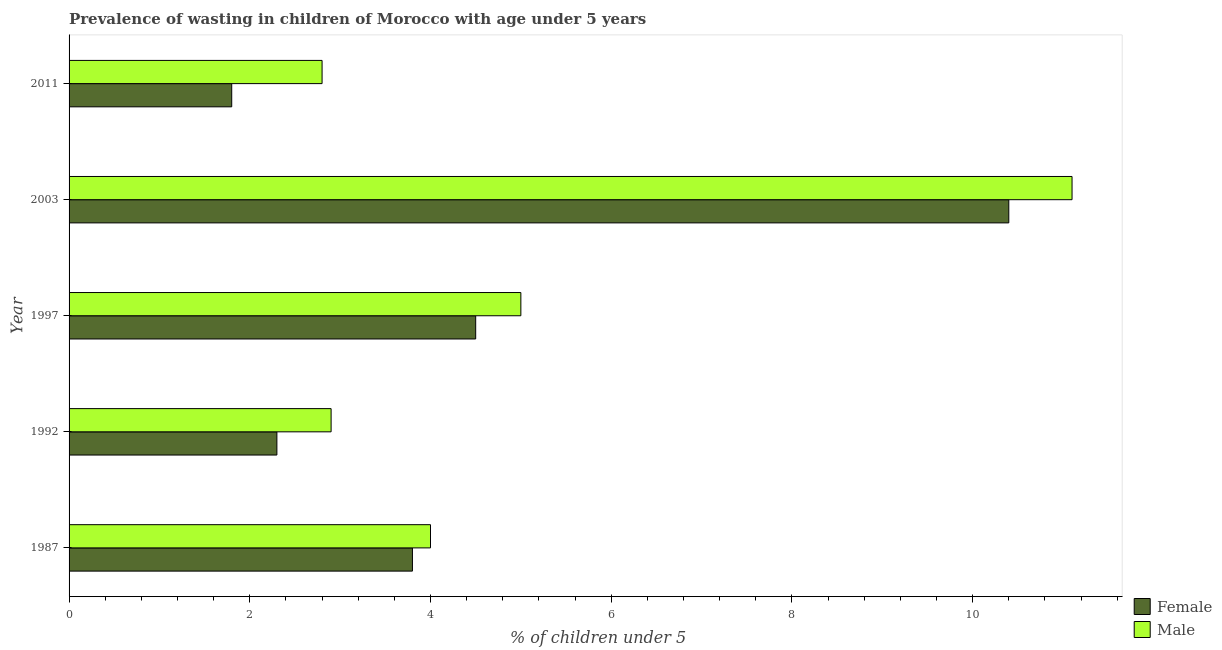Are the number of bars per tick equal to the number of legend labels?
Provide a short and direct response. Yes. Are the number of bars on each tick of the Y-axis equal?
Keep it short and to the point. Yes. How many bars are there on the 5th tick from the top?
Make the answer very short. 2. In how many cases, is the number of bars for a given year not equal to the number of legend labels?
Offer a terse response. 0. What is the percentage of undernourished female children in 2003?
Keep it short and to the point. 10.4. Across all years, what is the maximum percentage of undernourished male children?
Make the answer very short. 11.1. Across all years, what is the minimum percentage of undernourished male children?
Keep it short and to the point. 2.8. In which year was the percentage of undernourished male children maximum?
Give a very brief answer. 2003. In which year was the percentage of undernourished male children minimum?
Your answer should be very brief. 2011. What is the total percentage of undernourished male children in the graph?
Offer a very short reply. 25.8. What is the difference between the percentage of undernourished female children in 1992 and that in 2011?
Offer a very short reply. 0.5. What is the difference between the percentage of undernourished male children in 1997 and the percentage of undernourished female children in 1987?
Your response must be concise. 1.2. What is the average percentage of undernourished female children per year?
Ensure brevity in your answer.  4.56. In the year 2011, what is the difference between the percentage of undernourished male children and percentage of undernourished female children?
Your answer should be compact. 1. What is the ratio of the percentage of undernourished male children in 1987 to that in 2003?
Your answer should be very brief. 0.36. Is the percentage of undernourished male children in 1987 less than that in 1992?
Offer a very short reply. No. Is the difference between the percentage of undernourished male children in 1987 and 2003 greater than the difference between the percentage of undernourished female children in 1987 and 2003?
Your answer should be compact. No. What is the difference between the highest and the second highest percentage of undernourished male children?
Your response must be concise. 6.1. How many bars are there?
Make the answer very short. 10. What is the difference between two consecutive major ticks on the X-axis?
Keep it short and to the point. 2. Does the graph contain grids?
Provide a short and direct response. No. Where does the legend appear in the graph?
Your response must be concise. Bottom right. How are the legend labels stacked?
Provide a succinct answer. Vertical. What is the title of the graph?
Offer a terse response. Prevalence of wasting in children of Morocco with age under 5 years. Does "Sanitation services" appear as one of the legend labels in the graph?
Your response must be concise. No. What is the label or title of the X-axis?
Provide a short and direct response.  % of children under 5. What is the  % of children under 5 in Female in 1987?
Make the answer very short. 3.8. What is the  % of children under 5 in Female in 1992?
Ensure brevity in your answer.  2.3. What is the  % of children under 5 in Male in 1992?
Provide a succinct answer. 2.9. What is the  % of children under 5 in Female in 1997?
Offer a very short reply. 4.5. What is the  % of children under 5 in Male in 1997?
Give a very brief answer. 5. What is the  % of children under 5 of Female in 2003?
Offer a very short reply. 10.4. What is the  % of children under 5 in Male in 2003?
Offer a terse response. 11.1. What is the  % of children under 5 in Female in 2011?
Provide a short and direct response. 1.8. What is the  % of children under 5 in Male in 2011?
Your response must be concise. 2.8. Across all years, what is the maximum  % of children under 5 of Female?
Make the answer very short. 10.4. Across all years, what is the maximum  % of children under 5 in Male?
Make the answer very short. 11.1. Across all years, what is the minimum  % of children under 5 of Female?
Provide a succinct answer. 1.8. Across all years, what is the minimum  % of children under 5 in Male?
Your answer should be compact. 2.8. What is the total  % of children under 5 in Female in the graph?
Give a very brief answer. 22.8. What is the total  % of children under 5 in Male in the graph?
Give a very brief answer. 25.8. What is the difference between the  % of children under 5 in Female in 1987 and that in 1997?
Ensure brevity in your answer.  -0.7. What is the difference between the  % of children under 5 in Male in 1987 and that in 1997?
Give a very brief answer. -1. What is the difference between the  % of children under 5 of Female in 1987 and that in 2003?
Your response must be concise. -6.6. What is the difference between the  % of children under 5 of Female in 1992 and that in 2011?
Make the answer very short. 0.5. What is the difference between the  % of children under 5 of Male in 1992 and that in 2011?
Keep it short and to the point. 0.1. What is the difference between the  % of children under 5 of Female in 1997 and that in 2011?
Your response must be concise. 2.7. What is the difference between the  % of children under 5 in Female in 2003 and that in 2011?
Offer a very short reply. 8.6. What is the difference between the  % of children under 5 in Female in 1987 and the  % of children under 5 in Male in 1992?
Provide a succinct answer. 0.9. What is the difference between the  % of children under 5 in Female in 1987 and the  % of children under 5 in Male in 2011?
Your answer should be very brief. 1. What is the difference between the  % of children under 5 in Female in 1997 and the  % of children under 5 in Male in 2011?
Your answer should be compact. 1.7. What is the difference between the  % of children under 5 in Female in 2003 and the  % of children under 5 in Male in 2011?
Keep it short and to the point. 7.6. What is the average  % of children under 5 of Female per year?
Give a very brief answer. 4.56. What is the average  % of children under 5 of Male per year?
Ensure brevity in your answer.  5.16. In the year 1987, what is the difference between the  % of children under 5 in Female and  % of children under 5 in Male?
Keep it short and to the point. -0.2. In the year 1992, what is the difference between the  % of children under 5 of Female and  % of children under 5 of Male?
Provide a short and direct response. -0.6. In the year 1997, what is the difference between the  % of children under 5 of Female and  % of children under 5 of Male?
Keep it short and to the point. -0.5. What is the ratio of the  % of children under 5 in Female in 1987 to that in 1992?
Your answer should be compact. 1.65. What is the ratio of the  % of children under 5 of Male in 1987 to that in 1992?
Make the answer very short. 1.38. What is the ratio of the  % of children under 5 in Female in 1987 to that in 1997?
Ensure brevity in your answer.  0.84. What is the ratio of the  % of children under 5 of Male in 1987 to that in 1997?
Provide a succinct answer. 0.8. What is the ratio of the  % of children under 5 in Female in 1987 to that in 2003?
Your answer should be compact. 0.37. What is the ratio of the  % of children under 5 in Male in 1987 to that in 2003?
Provide a short and direct response. 0.36. What is the ratio of the  % of children under 5 of Female in 1987 to that in 2011?
Make the answer very short. 2.11. What is the ratio of the  % of children under 5 of Male in 1987 to that in 2011?
Provide a succinct answer. 1.43. What is the ratio of the  % of children under 5 in Female in 1992 to that in 1997?
Provide a succinct answer. 0.51. What is the ratio of the  % of children under 5 of Male in 1992 to that in 1997?
Your response must be concise. 0.58. What is the ratio of the  % of children under 5 in Female in 1992 to that in 2003?
Provide a short and direct response. 0.22. What is the ratio of the  % of children under 5 of Male in 1992 to that in 2003?
Your response must be concise. 0.26. What is the ratio of the  % of children under 5 in Female in 1992 to that in 2011?
Give a very brief answer. 1.28. What is the ratio of the  % of children under 5 in Male in 1992 to that in 2011?
Offer a very short reply. 1.04. What is the ratio of the  % of children under 5 of Female in 1997 to that in 2003?
Ensure brevity in your answer.  0.43. What is the ratio of the  % of children under 5 of Male in 1997 to that in 2003?
Make the answer very short. 0.45. What is the ratio of the  % of children under 5 of Male in 1997 to that in 2011?
Offer a terse response. 1.79. What is the ratio of the  % of children under 5 in Female in 2003 to that in 2011?
Provide a succinct answer. 5.78. What is the ratio of the  % of children under 5 of Male in 2003 to that in 2011?
Give a very brief answer. 3.96. What is the difference between the highest and the second highest  % of children under 5 in Male?
Provide a short and direct response. 6.1. 